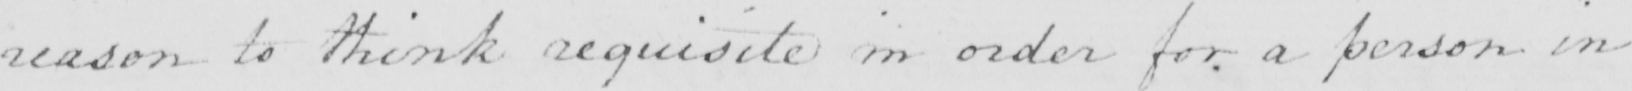What text is written in this handwritten line? reason to think requisite in order for a person in 